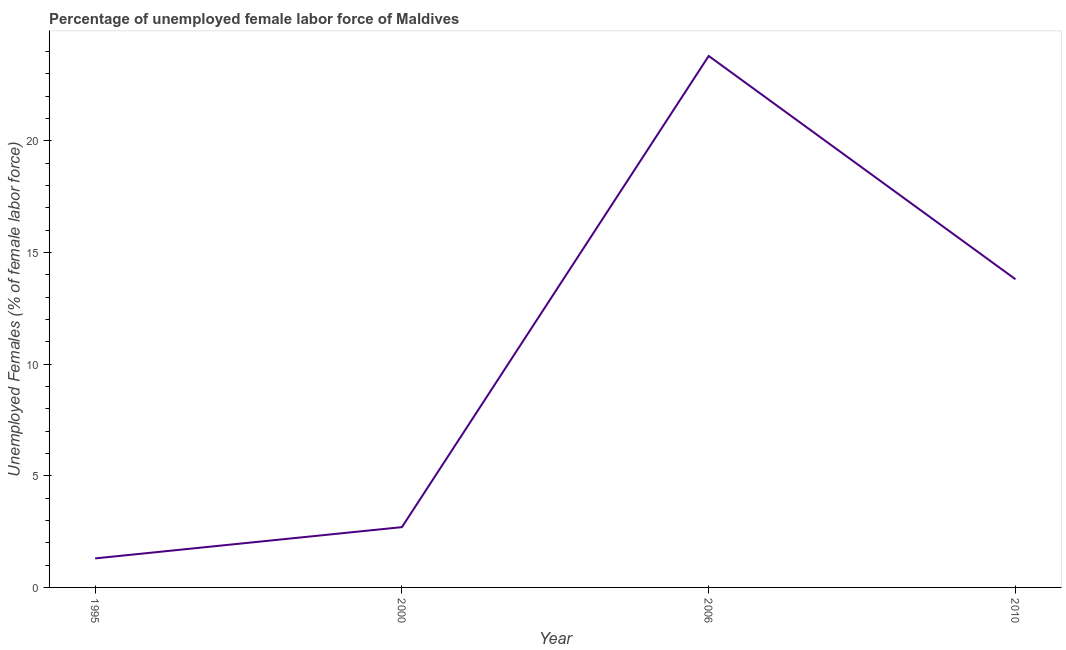What is the total unemployed female labour force in 2000?
Provide a short and direct response. 2.7. Across all years, what is the maximum total unemployed female labour force?
Offer a very short reply. 23.8. Across all years, what is the minimum total unemployed female labour force?
Your answer should be compact. 1.3. What is the sum of the total unemployed female labour force?
Your answer should be very brief. 41.6. What is the difference between the total unemployed female labour force in 1995 and 2010?
Offer a very short reply. -12.5. What is the average total unemployed female labour force per year?
Your answer should be compact. 10.4. What is the median total unemployed female labour force?
Provide a short and direct response. 8.25. In how many years, is the total unemployed female labour force greater than 14 %?
Give a very brief answer. 1. Do a majority of the years between 1995 and 2006 (inclusive) have total unemployed female labour force greater than 8 %?
Provide a short and direct response. No. What is the ratio of the total unemployed female labour force in 1995 to that in 2010?
Your answer should be very brief. 0.09. What is the difference between the highest and the second highest total unemployed female labour force?
Your answer should be very brief. 10. What is the difference between the highest and the lowest total unemployed female labour force?
Offer a very short reply. 22.5. Does the total unemployed female labour force monotonically increase over the years?
Your response must be concise. No. How many lines are there?
Ensure brevity in your answer.  1. How many years are there in the graph?
Offer a terse response. 4. Are the values on the major ticks of Y-axis written in scientific E-notation?
Offer a very short reply. No. Does the graph contain any zero values?
Your answer should be very brief. No. What is the title of the graph?
Your response must be concise. Percentage of unemployed female labor force of Maldives. What is the label or title of the X-axis?
Make the answer very short. Year. What is the label or title of the Y-axis?
Provide a succinct answer. Unemployed Females (% of female labor force). What is the Unemployed Females (% of female labor force) of 1995?
Your response must be concise. 1.3. What is the Unemployed Females (% of female labor force) of 2000?
Keep it short and to the point. 2.7. What is the Unemployed Females (% of female labor force) in 2006?
Keep it short and to the point. 23.8. What is the Unemployed Females (% of female labor force) in 2010?
Give a very brief answer. 13.8. What is the difference between the Unemployed Females (% of female labor force) in 1995 and 2000?
Provide a succinct answer. -1.4. What is the difference between the Unemployed Females (% of female labor force) in 1995 and 2006?
Keep it short and to the point. -22.5. What is the difference between the Unemployed Females (% of female labor force) in 1995 and 2010?
Make the answer very short. -12.5. What is the difference between the Unemployed Females (% of female labor force) in 2000 and 2006?
Ensure brevity in your answer.  -21.1. What is the difference between the Unemployed Females (% of female labor force) in 2006 and 2010?
Provide a succinct answer. 10. What is the ratio of the Unemployed Females (% of female labor force) in 1995 to that in 2000?
Your answer should be compact. 0.48. What is the ratio of the Unemployed Females (% of female labor force) in 1995 to that in 2006?
Provide a short and direct response. 0.06. What is the ratio of the Unemployed Females (% of female labor force) in 1995 to that in 2010?
Your answer should be compact. 0.09. What is the ratio of the Unemployed Females (% of female labor force) in 2000 to that in 2006?
Your answer should be compact. 0.11. What is the ratio of the Unemployed Females (% of female labor force) in 2000 to that in 2010?
Your response must be concise. 0.2. What is the ratio of the Unemployed Females (% of female labor force) in 2006 to that in 2010?
Offer a terse response. 1.73. 